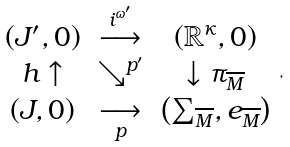Convert formula to latex. <formula><loc_0><loc_0><loc_500><loc_500>\begin{array} { c c c } \left ( J ^ { \prime } , 0 \right ) & \overset { i ^ { \omega ^ { \prime } } } { \longrightarrow } & \left ( \mathbb { R } ^ { \kappa } , 0 \right ) \\ h \uparrow & \searrow ^ { p ^ { \prime } } & \downarrow \pi _ { \overline { M } } \\ \left ( J , 0 \right ) & \underset { p } { \longrightarrow } & \left ( \sum _ { \overline { M } } , e _ { \overline { M } } \right ) \end{array} ,</formula> 